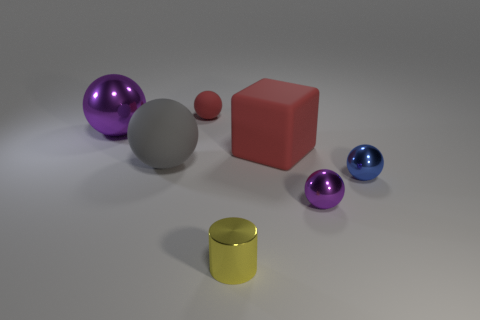There is another rubber thing that is the same shape as the tiny red thing; what size is it?
Make the answer very short. Large. The large thing right of the small object behind the rubber object that is in front of the red block is made of what material?
Make the answer very short. Rubber. Are there any tiny purple metallic things?
Your response must be concise. Yes. Do the tiny rubber object and the big object right of the big gray matte thing have the same color?
Offer a terse response. Yes. What color is the small rubber thing?
Make the answer very short. Red. Is there anything else that is the same shape as the large red rubber object?
Ensure brevity in your answer.  No. What is the color of the big rubber thing that is the same shape as the tiny purple object?
Your response must be concise. Gray. Does the gray matte object have the same shape as the small red thing?
Your response must be concise. Yes. What number of cubes are purple metal things or tiny rubber things?
Your response must be concise. 0. What color is the other tiny sphere that is the same material as the small purple ball?
Offer a terse response. Blue. 